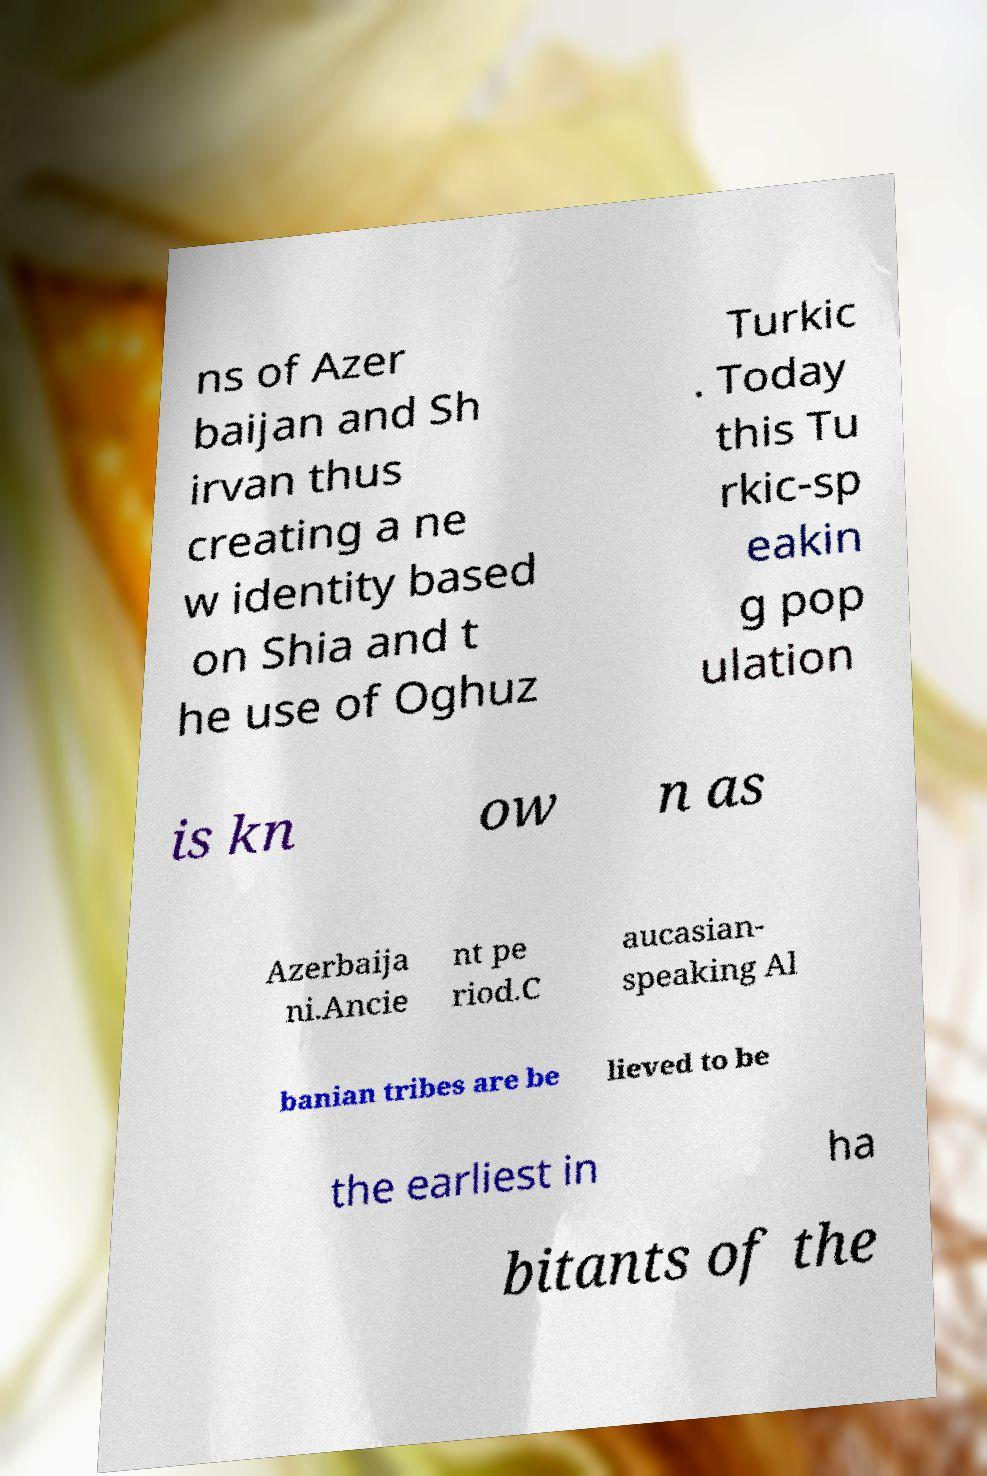Please identify and transcribe the text found in this image. ns of Azer baijan and Sh irvan thus creating a ne w identity based on Shia and t he use of Oghuz Turkic . Today this Tu rkic-sp eakin g pop ulation is kn ow n as Azerbaija ni.Ancie nt pe riod.C aucasian- speaking Al banian tribes are be lieved to be the earliest in ha bitants of the 